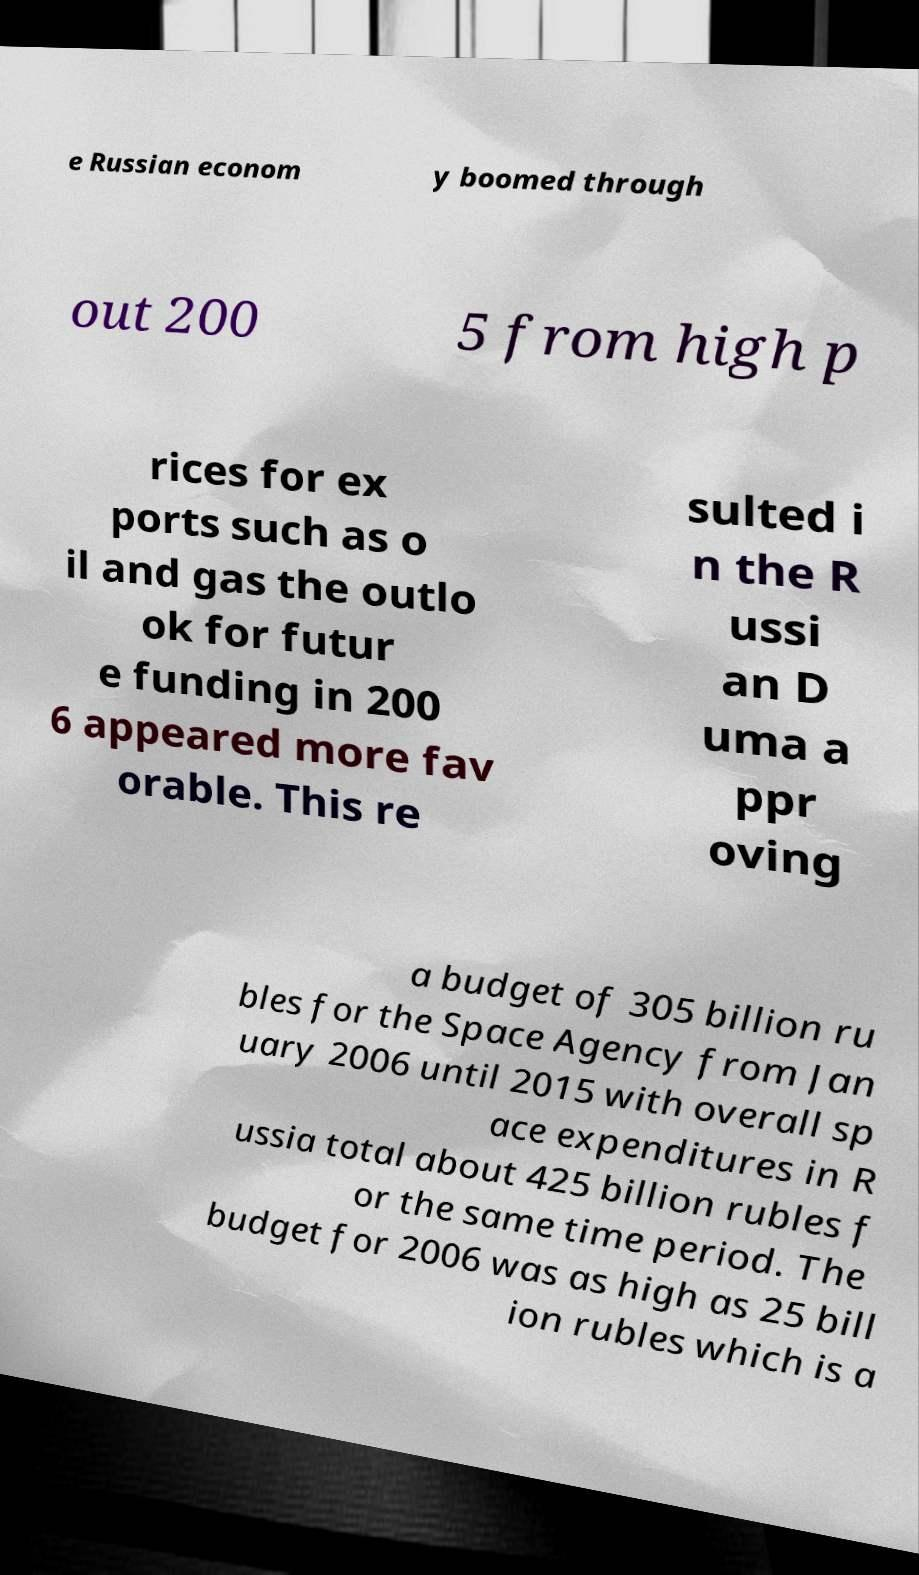Could you extract and type out the text from this image? e Russian econom y boomed through out 200 5 from high p rices for ex ports such as o il and gas the outlo ok for futur e funding in 200 6 appeared more fav orable. This re sulted i n the R ussi an D uma a ppr oving a budget of 305 billion ru bles for the Space Agency from Jan uary 2006 until 2015 with overall sp ace expenditures in R ussia total about 425 billion rubles f or the same time period. The budget for 2006 was as high as 25 bill ion rubles which is a 